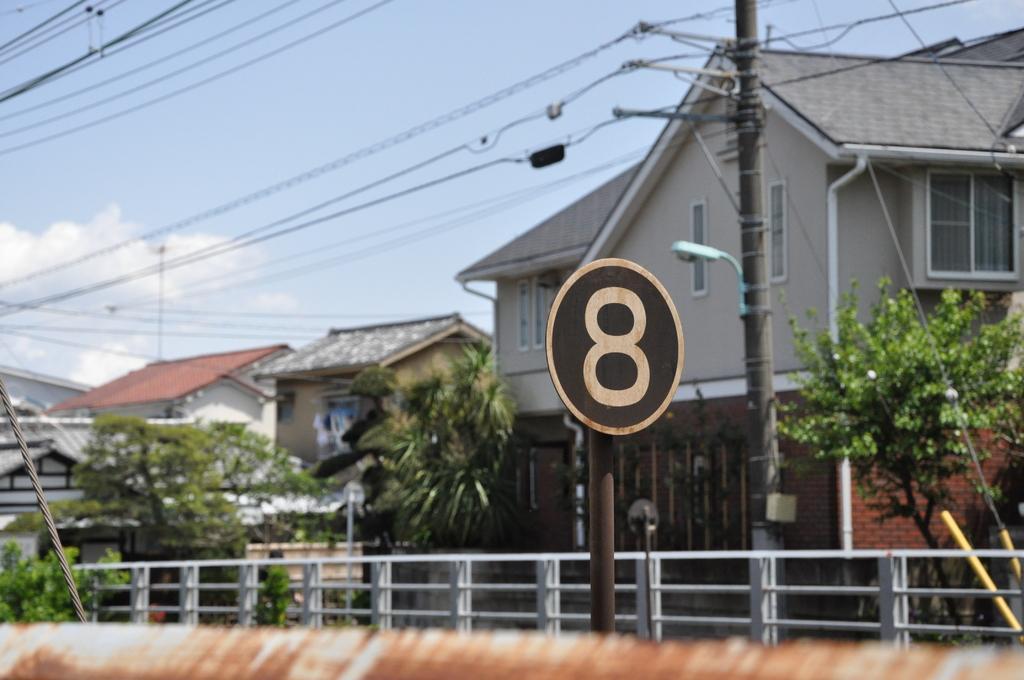Could you give a brief overview of what you see in this image? In the image we can see there is ¨8¨ number board and there are iron pole fencing. There are trees and there is electrical wires pole. Behind there are buildings and the sky is clear. 